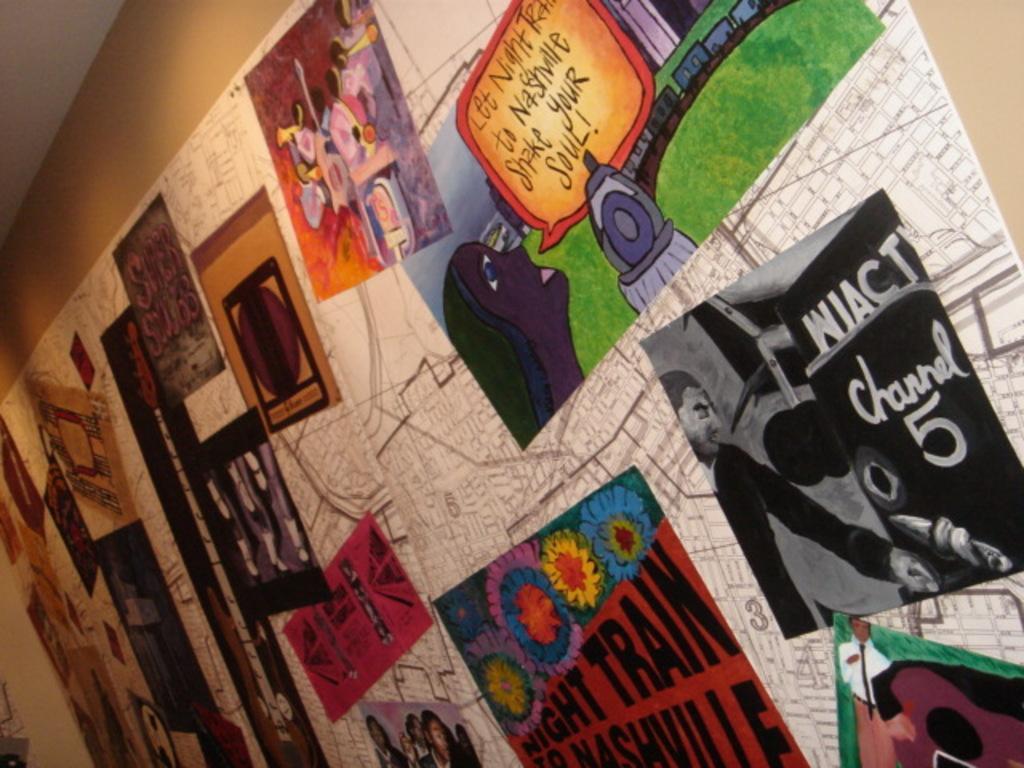Can you describe this image briefly? In this image we can see a wall. On the wall we can see posters and the posters contains some text and images. In the top left, we can see a roof. 